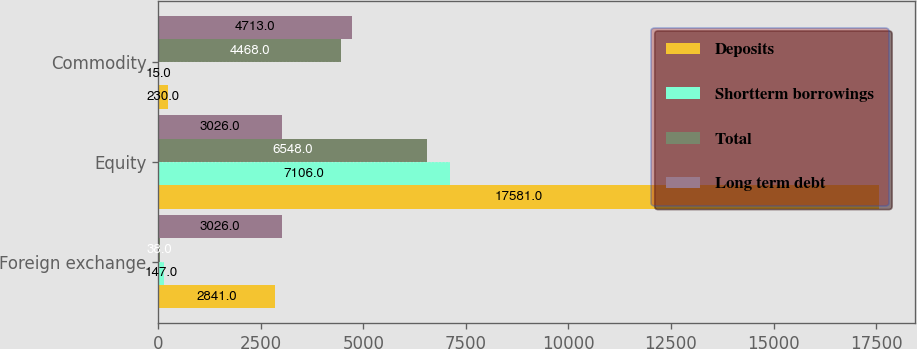Convert chart. <chart><loc_0><loc_0><loc_500><loc_500><stacked_bar_chart><ecel><fcel>Foreign exchange<fcel>Equity<fcel>Commodity<nl><fcel>Deposits<fcel>2841<fcel>17581<fcel>230<nl><fcel>Shortterm borrowings<fcel>147<fcel>7106<fcel>15<nl><fcel>Total<fcel>38<fcel>6548<fcel>4468<nl><fcel>Long term debt<fcel>3026<fcel>3026<fcel>4713<nl></chart> 